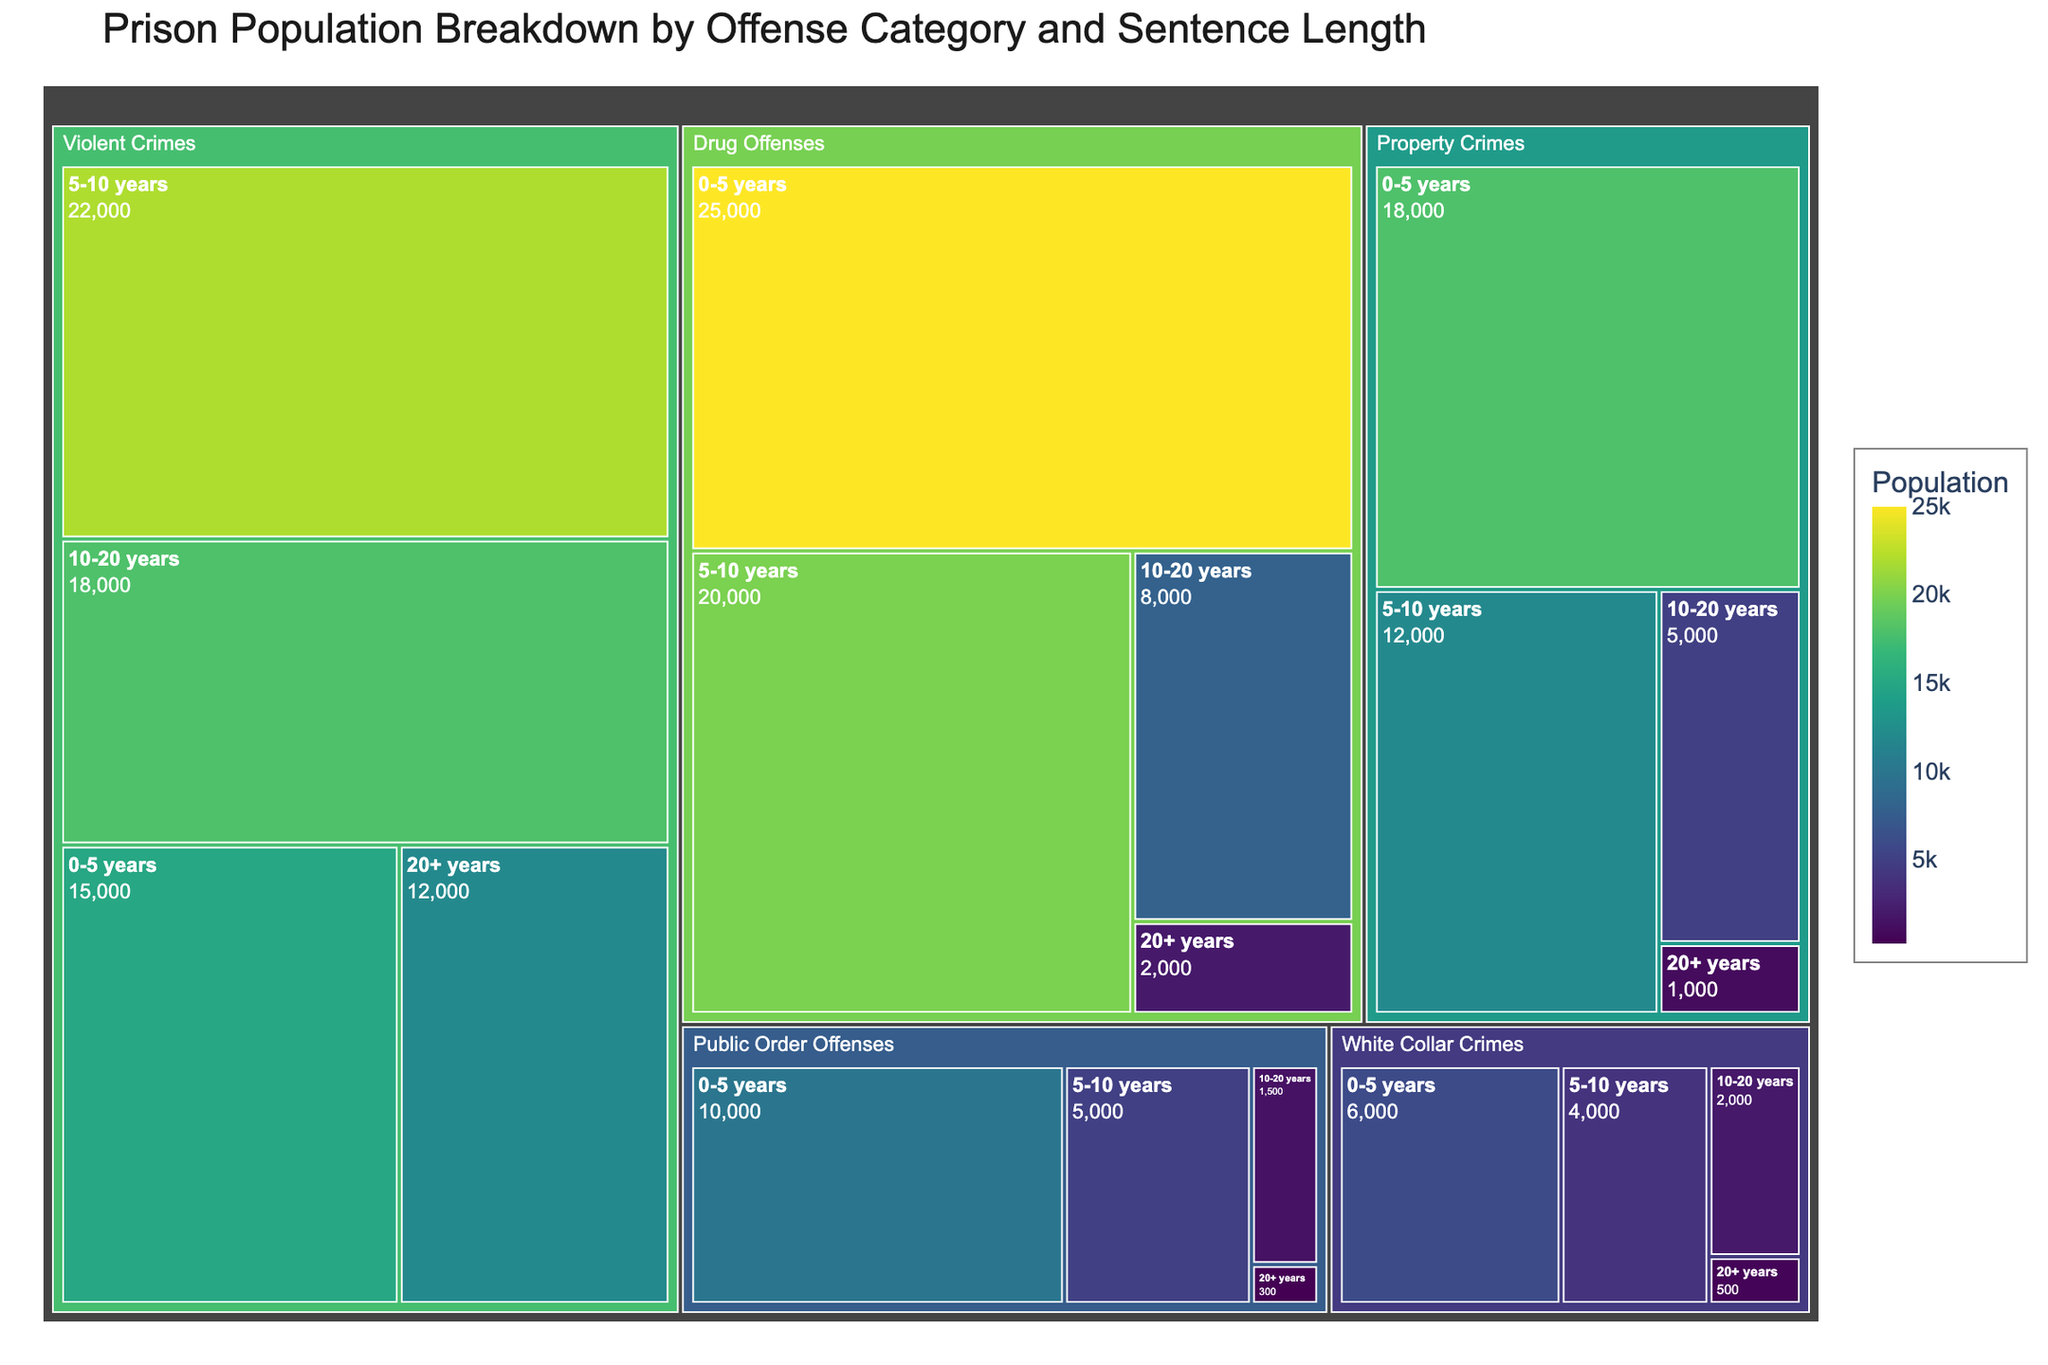What is the title of the treemap? The title of the treemap is usually displayed prominently at the top and describes what the figure represents. Here, it shows "Prison Population Breakdown by Offense Category and Sentence Length".
Answer: Prison Population Breakdown by Offense Category and Sentence Length Which offense category has the largest population for sentences of 0-5 years? To determine this, look within the different sections for each "0-5 years" group and compare their populations. The "Drug Offenses" section for 0-5 years clearly has more population than the others with 25,000, followed by Property Crimes at 18,000.
Answer: Drug Offenses What is the total population for Drug Offenses? Sum the populations for Drug Offenses across all sentence lengths: 25,000 (0-5 years) + 20,000 (5-10 years) + 8,000 (10-20 years) + 2,000 (20+ years). This equals 55,000.
Answer: 55,000 Which sentence length has the smallest population for Public Order Offenses? Compare the populations for Public Order Offenses across all sentence lengths. The smallest population is in "20+ years" which is 300.
Answer: 20+ years How does the population for Violent Crimes compare to Property Crimes in the 5-10 years category? Look at the populations for each crime in the 5-10 years category. Violent Crimes have a population of 22,000, whereas Property Crimes have 12,000. Violent Crimes have a larger population than Property Crimes in this category.
Answer: Violent Crimes have a larger population What is the total population for offenses with sentences longer than 20 years? Sum the populations for each offense category with sentence lengths of 20+ years: 12,000 (Violent Crimes) + 2,000 (Drug Offenses) + 1,000 (Property Crimes) + 500 (White Collar Crimes) + 300 (Public Order Offenses). This totals 15,800.
Answer: 15,800 Which offense category has the highest total population across all sentence lengths? Compare the total populations across all categories. Drug Offenses have the highest combined population by summing the values: 25,000 + 20,000 + 8,000 + 2,000 = 55,000.
Answer: Drug Offenses What is the difference between the populations of Property Crimes and White Collar Crimes for the 0-5 years sentence length? Subtract the population of White Collar Crimes (6,000) from the population of Property Crimes (18,000) in the 0-5 years category: 18,000 - 6,000 = 12,000.
Answer: 12,000 Which sentence length for White Collar Crimes has the highest population? Compare the values for White Collar Crimes across different sentence lengths. The highest population is in the "0-5 years" category, which is 6,000.
Answer: 0-5 years 